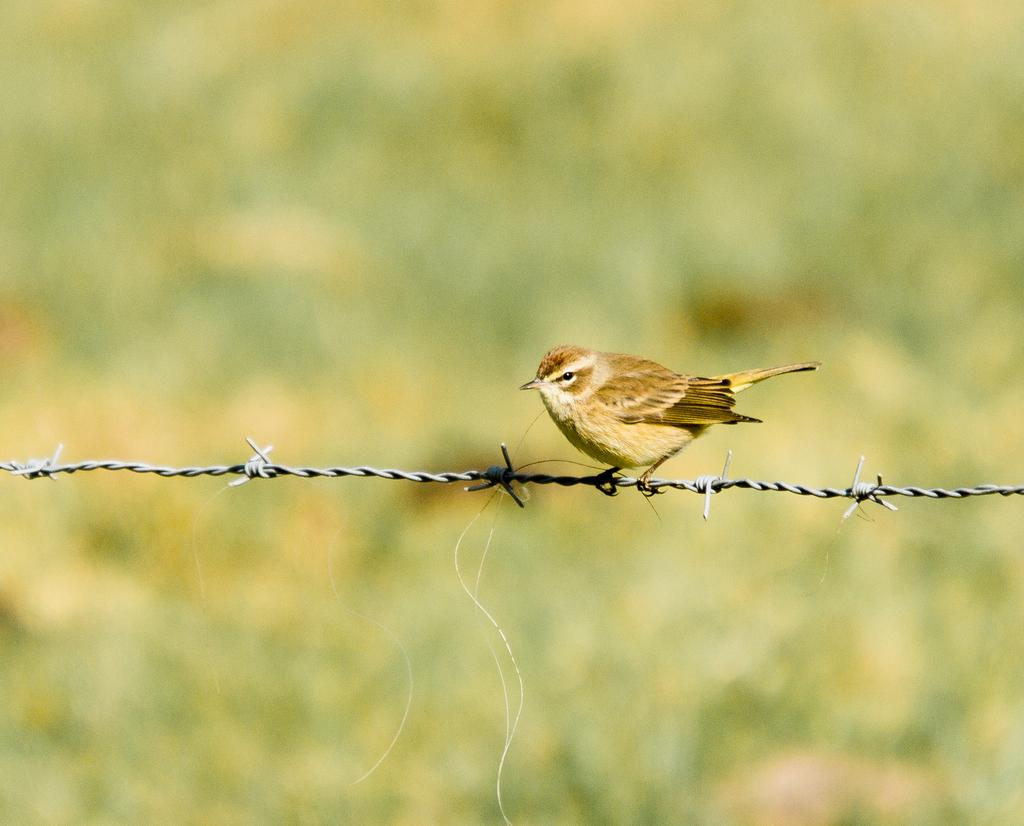What type of bird can be seen in the image? There is a sparrow in the image. Where is the sparrow located in the image? The sparrow is sitting on a fence. What type of surface is visible on the floor in the image? There is grass visible on the floor in the image. What type of ornament is hanging from the sparrow's beak in the image? There is no ornament hanging from the sparrow's beak in the image; the sparrow is simply sitting on a fence. 